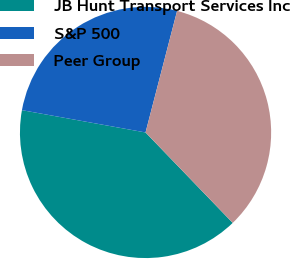Convert chart to OTSL. <chart><loc_0><loc_0><loc_500><loc_500><pie_chart><fcel>JB Hunt Transport Services Inc<fcel>S&P 500<fcel>Peer Group<nl><fcel>40.05%<fcel>26.2%<fcel>33.75%<nl></chart> 